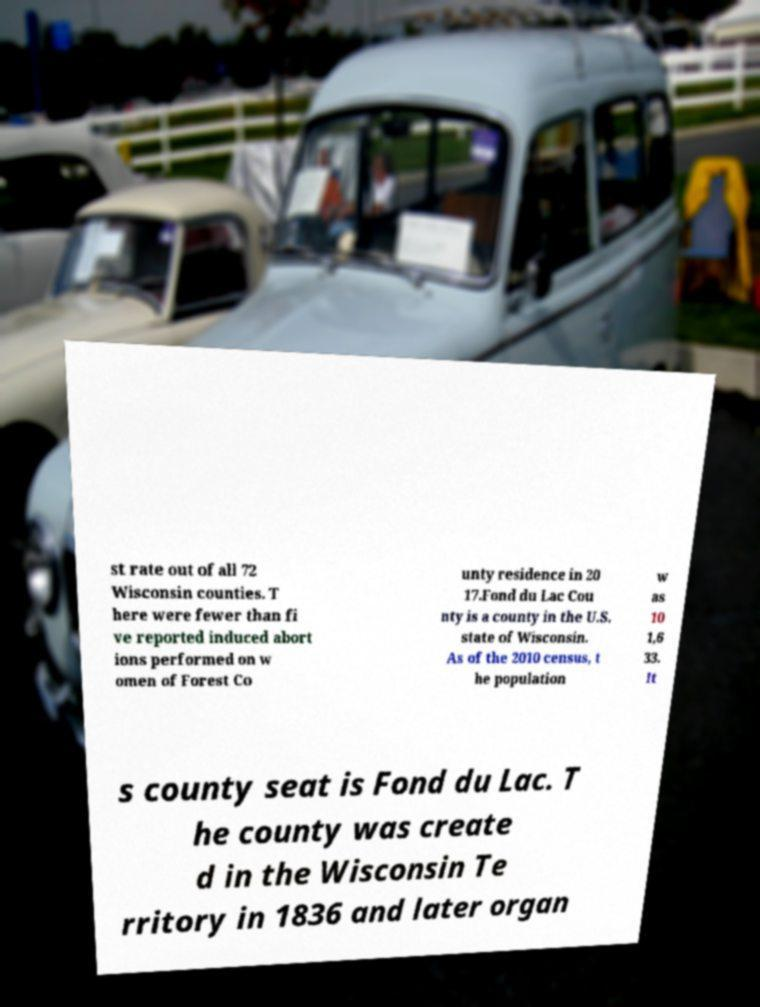Could you assist in decoding the text presented in this image and type it out clearly? st rate out of all 72 Wisconsin counties. T here were fewer than fi ve reported induced abort ions performed on w omen of Forest Co unty residence in 20 17.Fond du Lac Cou nty is a county in the U.S. state of Wisconsin. As of the 2010 census, t he population w as 10 1,6 33. It s county seat is Fond du Lac. T he county was create d in the Wisconsin Te rritory in 1836 and later organ 